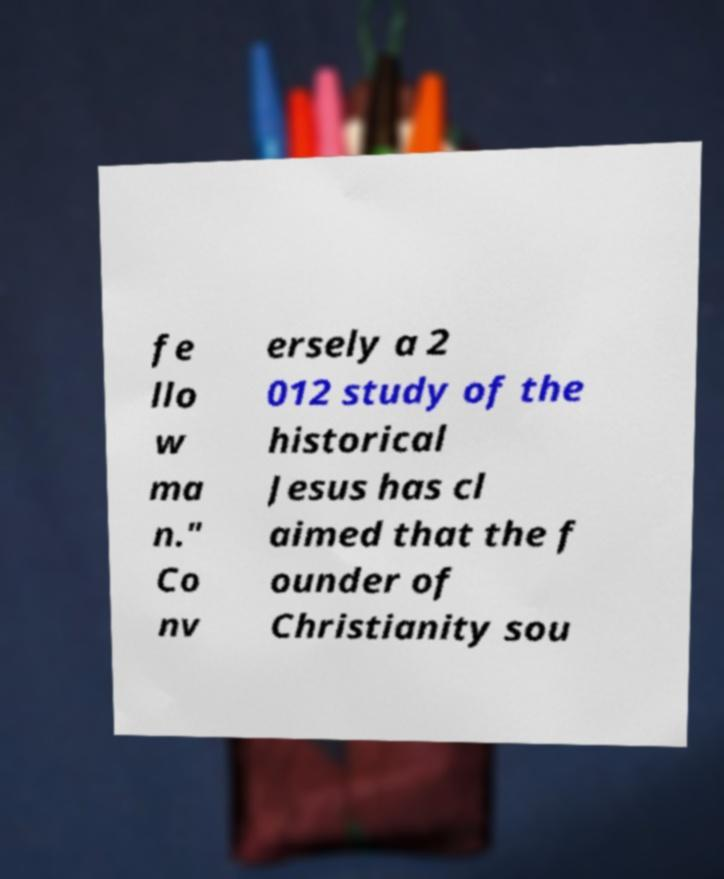Please identify and transcribe the text found in this image. fe llo w ma n." Co nv ersely a 2 012 study of the historical Jesus has cl aimed that the f ounder of Christianity sou 